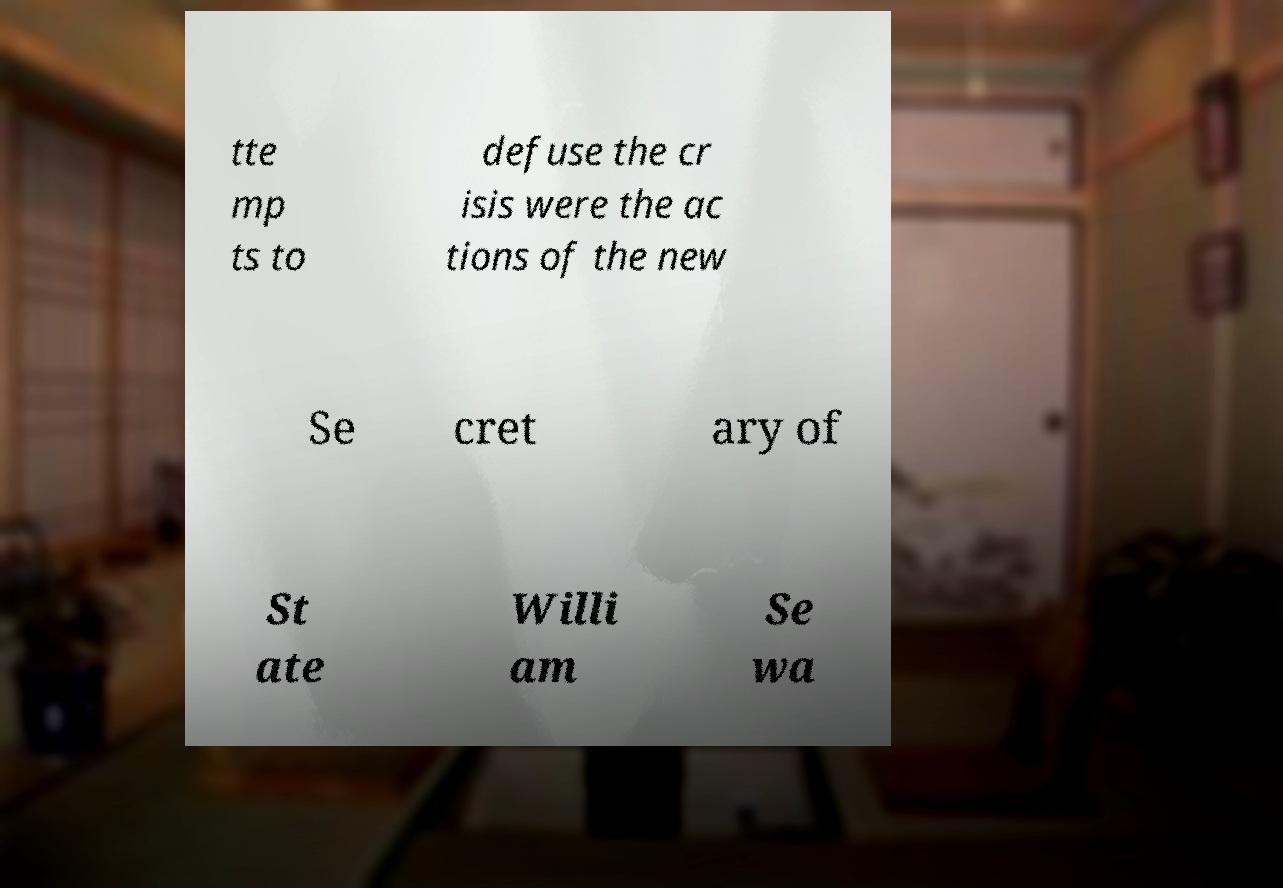For documentation purposes, I need the text within this image transcribed. Could you provide that? tte mp ts to defuse the cr isis were the ac tions of the new Se cret ary of St ate Willi am Se wa 